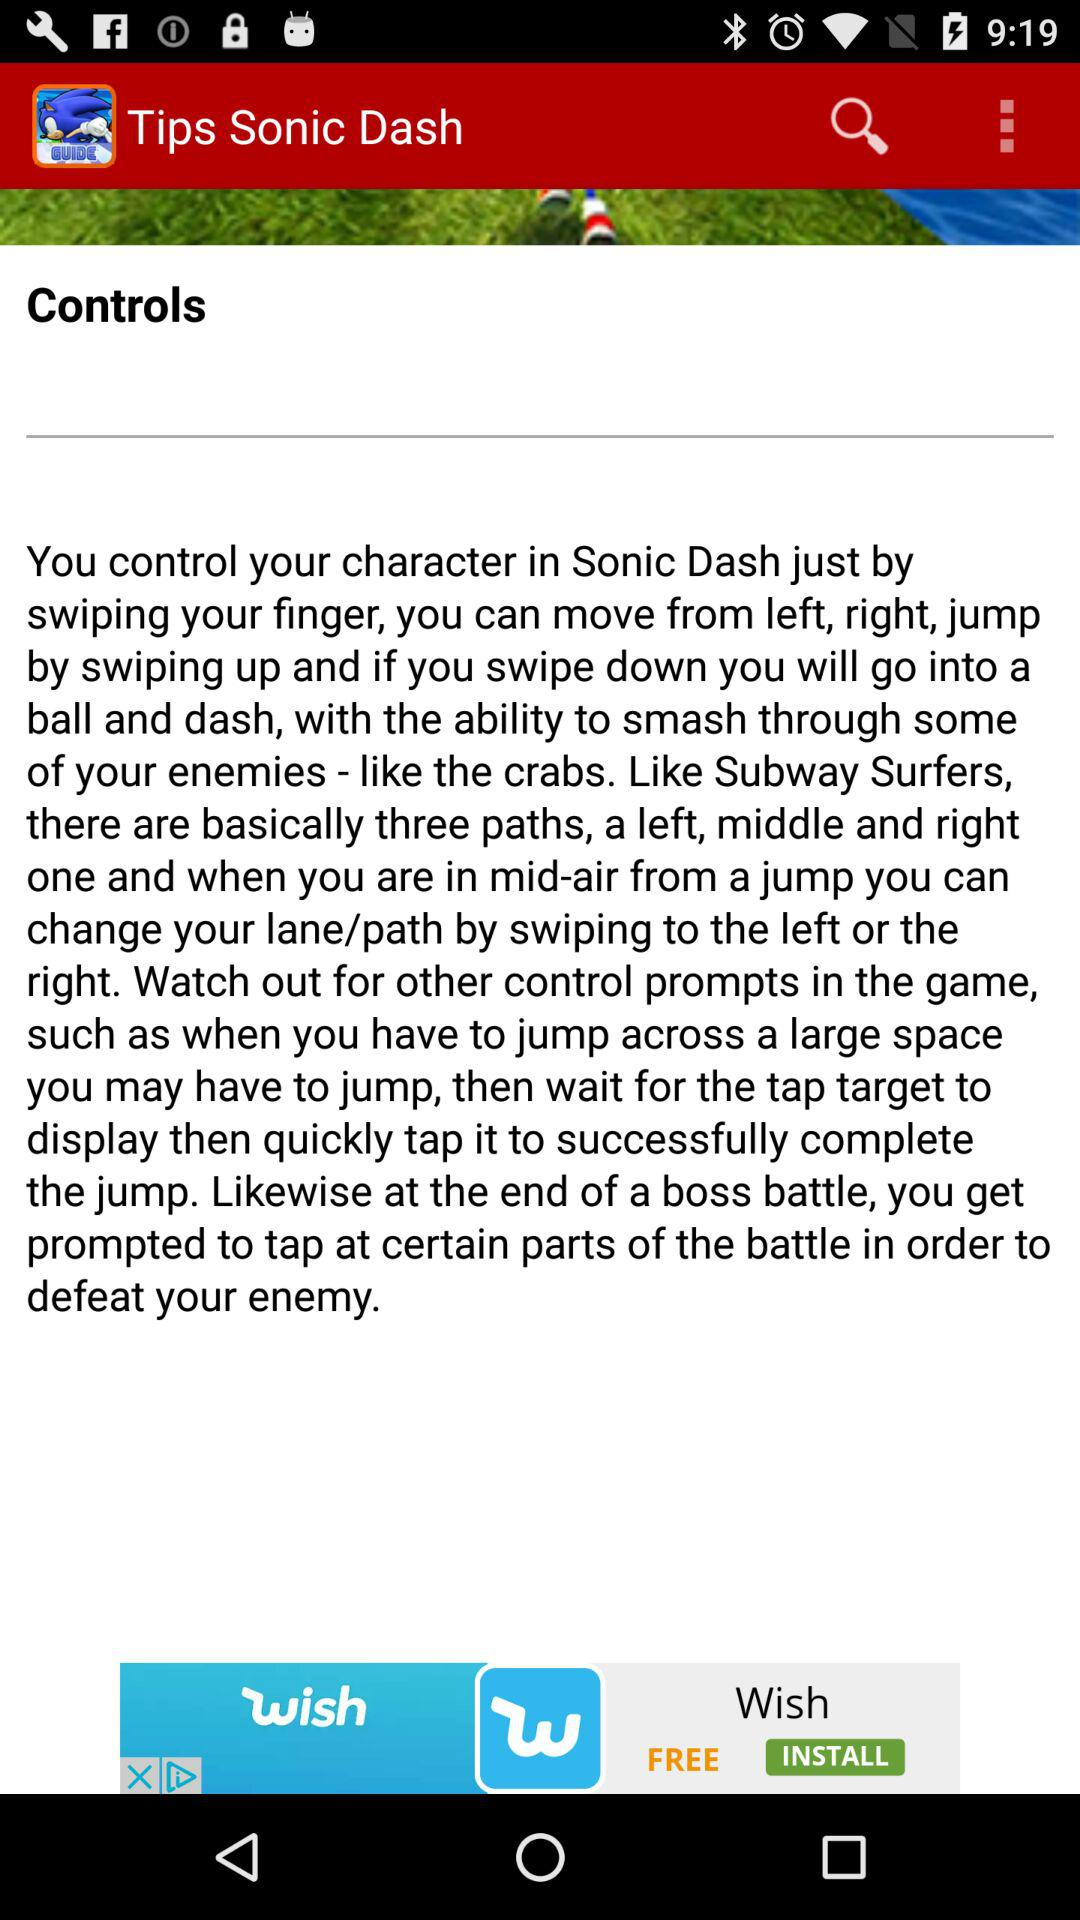What is the name of the application? The name of the application is "Tips Sonic Dash". 